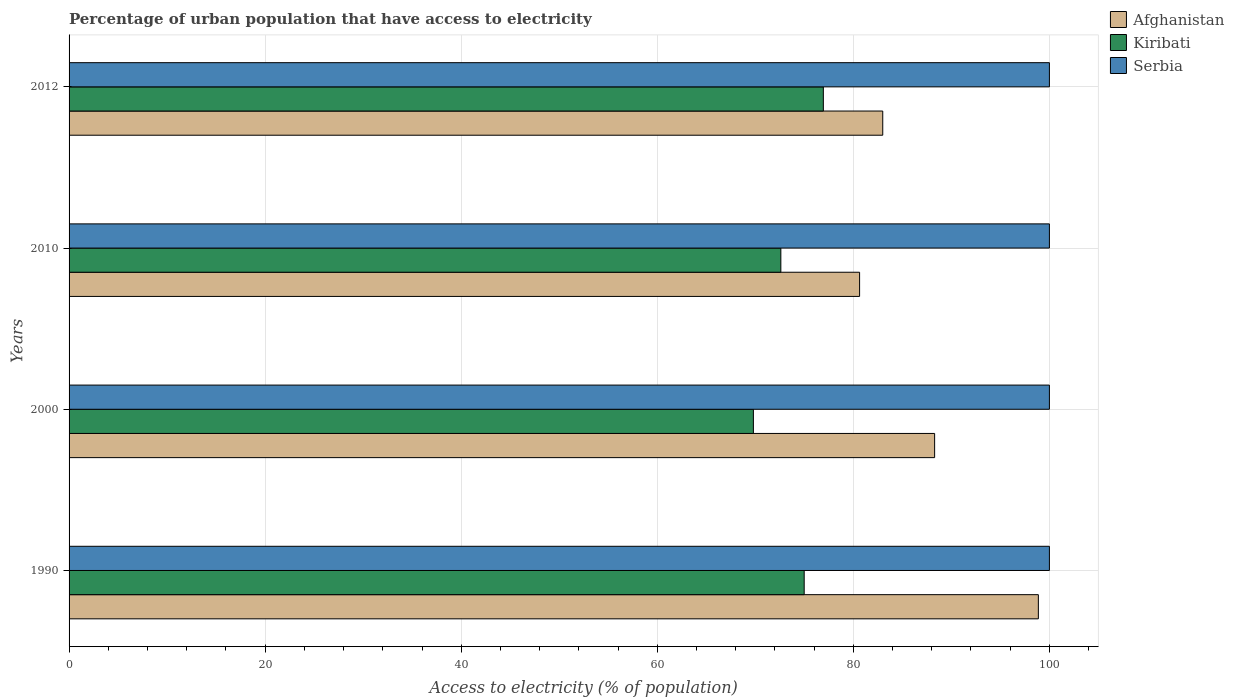Are the number of bars per tick equal to the number of legend labels?
Make the answer very short. Yes. How many bars are there on the 2nd tick from the bottom?
Provide a succinct answer. 3. In how many cases, is the number of bars for a given year not equal to the number of legend labels?
Give a very brief answer. 0. Across all years, what is the maximum percentage of urban population that have access to electricity in Kiribati?
Make the answer very short. 76.94. Across all years, what is the minimum percentage of urban population that have access to electricity in Serbia?
Provide a succinct answer. 100. In which year was the percentage of urban population that have access to electricity in Afghanistan minimum?
Ensure brevity in your answer.  2010. What is the total percentage of urban population that have access to electricity in Afghanistan in the graph?
Your answer should be compact. 350.8. What is the difference between the percentage of urban population that have access to electricity in Kiribati in 2010 and that in 2012?
Ensure brevity in your answer.  -4.34. What is the difference between the percentage of urban population that have access to electricity in Serbia in 2010 and the percentage of urban population that have access to electricity in Afghanistan in 2000?
Your response must be concise. 11.71. What is the average percentage of urban population that have access to electricity in Kiribati per year?
Keep it short and to the point. 73.58. In the year 2012, what is the difference between the percentage of urban population that have access to electricity in Kiribati and percentage of urban population that have access to electricity in Serbia?
Offer a very short reply. -23.06. What is the ratio of the percentage of urban population that have access to electricity in Kiribati in 2000 to that in 2010?
Provide a short and direct response. 0.96. Is the percentage of urban population that have access to electricity in Serbia in 1990 less than that in 2010?
Your response must be concise. No. Is the difference between the percentage of urban population that have access to electricity in Kiribati in 2000 and 2012 greater than the difference between the percentage of urban population that have access to electricity in Serbia in 2000 and 2012?
Offer a terse response. No. What is the difference between the highest and the second highest percentage of urban population that have access to electricity in Kiribati?
Give a very brief answer. 1.95. What is the difference between the highest and the lowest percentage of urban population that have access to electricity in Kiribati?
Keep it short and to the point. 7.13. What does the 2nd bar from the top in 1990 represents?
Keep it short and to the point. Kiribati. What does the 1st bar from the bottom in 2012 represents?
Your answer should be compact. Afghanistan. Is it the case that in every year, the sum of the percentage of urban population that have access to electricity in Afghanistan and percentage of urban population that have access to electricity in Kiribati is greater than the percentage of urban population that have access to electricity in Serbia?
Provide a short and direct response. Yes. Does the graph contain any zero values?
Provide a succinct answer. No. Does the graph contain grids?
Your answer should be very brief. Yes. How many legend labels are there?
Provide a short and direct response. 3. What is the title of the graph?
Provide a short and direct response. Percentage of urban population that have access to electricity. What is the label or title of the X-axis?
Keep it short and to the point. Access to electricity (% of population). What is the Access to electricity (% of population) in Afghanistan in 1990?
Keep it short and to the point. 98.87. What is the Access to electricity (% of population) in Kiribati in 1990?
Your answer should be compact. 74.99. What is the Access to electricity (% of population) of Afghanistan in 2000?
Provide a succinct answer. 88.29. What is the Access to electricity (% of population) in Kiribati in 2000?
Give a very brief answer. 69.8. What is the Access to electricity (% of population) of Serbia in 2000?
Give a very brief answer. 100. What is the Access to electricity (% of population) of Afghanistan in 2010?
Ensure brevity in your answer.  80.64. What is the Access to electricity (% of population) in Kiribati in 2010?
Provide a short and direct response. 72.6. What is the Access to electricity (% of population) in Afghanistan in 2012?
Offer a very short reply. 83. What is the Access to electricity (% of population) of Kiribati in 2012?
Provide a short and direct response. 76.94. Across all years, what is the maximum Access to electricity (% of population) in Afghanistan?
Your response must be concise. 98.87. Across all years, what is the maximum Access to electricity (% of population) in Kiribati?
Provide a short and direct response. 76.94. Across all years, what is the maximum Access to electricity (% of population) of Serbia?
Offer a very short reply. 100. Across all years, what is the minimum Access to electricity (% of population) of Afghanistan?
Offer a terse response. 80.64. Across all years, what is the minimum Access to electricity (% of population) of Kiribati?
Provide a short and direct response. 69.8. What is the total Access to electricity (% of population) in Afghanistan in the graph?
Ensure brevity in your answer.  350.8. What is the total Access to electricity (% of population) in Kiribati in the graph?
Keep it short and to the point. 294.33. What is the difference between the Access to electricity (% of population) in Afghanistan in 1990 and that in 2000?
Offer a terse response. 10.58. What is the difference between the Access to electricity (% of population) of Kiribati in 1990 and that in 2000?
Your answer should be very brief. 5.18. What is the difference between the Access to electricity (% of population) of Serbia in 1990 and that in 2000?
Keep it short and to the point. 0. What is the difference between the Access to electricity (% of population) in Afghanistan in 1990 and that in 2010?
Your response must be concise. 18.24. What is the difference between the Access to electricity (% of population) of Kiribati in 1990 and that in 2010?
Provide a short and direct response. 2.38. What is the difference between the Access to electricity (% of population) in Serbia in 1990 and that in 2010?
Your response must be concise. 0. What is the difference between the Access to electricity (% of population) in Afghanistan in 1990 and that in 2012?
Make the answer very short. 15.87. What is the difference between the Access to electricity (% of population) in Kiribati in 1990 and that in 2012?
Your answer should be compact. -1.95. What is the difference between the Access to electricity (% of population) of Serbia in 1990 and that in 2012?
Make the answer very short. 0. What is the difference between the Access to electricity (% of population) in Afghanistan in 2000 and that in 2010?
Your answer should be compact. 7.65. What is the difference between the Access to electricity (% of population) of Kiribati in 2000 and that in 2010?
Provide a short and direct response. -2.8. What is the difference between the Access to electricity (% of population) of Serbia in 2000 and that in 2010?
Provide a short and direct response. 0. What is the difference between the Access to electricity (% of population) of Afghanistan in 2000 and that in 2012?
Offer a very short reply. 5.29. What is the difference between the Access to electricity (% of population) of Kiribati in 2000 and that in 2012?
Your answer should be compact. -7.13. What is the difference between the Access to electricity (% of population) in Afghanistan in 2010 and that in 2012?
Your answer should be very brief. -2.36. What is the difference between the Access to electricity (% of population) in Kiribati in 2010 and that in 2012?
Your answer should be compact. -4.34. What is the difference between the Access to electricity (% of population) of Serbia in 2010 and that in 2012?
Offer a very short reply. 0. What is the difference between the Access to electricity (% of population) of Afghanistan in 1990 and the Access to electricity (% of population) of Kiribati in 2000?
Offer a very short reply. 29.07. What is the difference between the Access to electricity (% of population) of Afghanistan in 1990 and the Access to electricity (% of population) of Serbia in 2000?
Your answer should be compact. -1.13. What is the difference between the Access to electricity (% of population) of Kiribati in 1990 and the Access to electricity (% of population) of Serbia in 2000?
Offer a very short reply. -25.01. What is the difference between the Access to electricity (% of population) of Afghanistan in 1990 and the Access to electricity (% of population) of Kiribati in 2010?
Provide a short and direct response. 26.27. What is the difference between the Access to electricity (% of population) in Afghanistan in 1990 and the Access to electricity (% of population) in Serbia in 2010?
Provide a short and direct response. -1.13. What is the difference between the Access to electricity (% of population) in Kiribati in 1990 and the Access to electricity (% of population) in Serbia in 2010?
Provide a succinct answer. -25.01. What is the difference between the Access to electricity (% of population) in Afghanistan in 1990 and the Access to electricity (% of population) in Kiribati in 2012?
Offer a terse response. 21.93. What is the difference between the Access to electricity (% of population) of Afghanistan in 1990 and the Access to electricity (% of population) of Serbia in 2012?
Your response must be concise. -1.13. What is the difference between the Access to electricity (% of population) in Kiribati in 1990 and the Access to electricity (% of population) in Serbia in 2012?
Make the answer very short. -25.01. What is the difference between the Access to electricity (% of population) in Afghanistan in 2000 and the Access to electricity (% of population) in Kiribati in 2010?
Provide a short and direct response. 15.69. What is the difference between the Access to electricity (% of population) in Afghanistan in 2000 and the Access to electricity (% of population) in Serbia in 2010?
Give a very brief answer. -11.71. What is the difference between the Access to electricity (% of population) in Kiribati in 2000 and the Access to electricity (% of population) in Serbia in 2010?
Keep it short and to the point. -30.2. What is the difference between the Access to electricity (% of population) of Afghanistan in 2000 and the Access to electricity (% of population) of Kiribati in 2012?
Give a very brief answer. 11.35. What is the difference between the Access to electricity (% of population) in Afghanistan in 2000 and the Access to electricity (% of population) in Serbia in 2012?
Your answer should be compact. -11.71. What is the difference between the Access to electricity (% of population) in Kiribati in 2000 and the Access to electricity (% of population) in Serbia in 2012?
Make the answer very short. -30.2. What is the difference between the Access to electricity (% of population) of Afghanistan in 2010 and the Access to electricity (% of population) of Kiribati in 2012?
Your response must be concise. 3.7. What is the difference between the Access to electricity (% of population) in Afghanistan in 2010 and the Access to electricity (% of population) in Serbia in 2012?
Keep it short and to the point. -19.36. What is the difference between the Access to electricity (% of population) of Kiribati in 2010 and the Access to electricity (% of population) of Serbia in 2012?
Your answer should be compact. -27.4. What is the average Access to electricity (% of population) in Afghanistan per year?
Provide a short and direct response. 87.7. What is the average Access to electricity (% of population) in Kiribati per year?
Your response must be concise. 73.58. In the year 1990, what is the difference between the Access to electricity (% of population) in Afghanistan and Access to electricity (% of population) in Kiribati?
Your response must be concise. 23.89. In the year 1990, what is the difference between the Access to electricity (% of population) of Afghanistan and Access to electricity (% of population) of Serbia?
Offer a very short reply. -1.13. In the year 1990, what is the difference between the Access to electricity (% of population) of Kiribati and Access to electricity (% of population) of Serbia?
Ensure brevity in your answer.  -25.01. In the year 2000, what is the difference between the Access to electricity (% of population) in Afghanistan and Access to electricity (% of population) in Kiribati?
Offer a very short reply. 18.49. In the year 2000, what is the difference between the Access to electricity (% of population) in Afghanistan and Access to electricity (% of population) in Serbia?
Offer a very short reply. -11.71. In the year 2000, what is the difference between the Access to electricity (% of population) in Kiribati and Access to electricity (% of population) in Serbia?
Offer a terse response. -30.2. In the year 2010, what is the difference between the Access to electricity (% of population) in Afghanistan and Access to electricity (% of population) in Kiribati?
Offer a terse response. 8.03. In the year 2010, what is the difference between the Access to electricity (% of population) in Afghanistan and Access to electricity (% of population) in Serbia?
Ensure brevity in your answer.  -19.36. In the year 2010, what is the difference between the Access to electricity (% of population) of Kiribati and Access to electricity (% of population) of Serbia?
Provide a short and direct response. -27.4. In the year 2012, what is the difference between the Access to electricity (% of population) in Afghanistan and Access to electricity (% of population) in Kiribati?
Make the answer very short. 6.06. In the year 2012, what is the difference between the Access to electricity (% of population) in Afghanistan and Access to electricity (% of population) in Serbia?
Keep it short and to the point. -17. In the year 2012, what is the difference between the Access to electricity (% of population) in Kiribati and Access to electricity (% of population) in Serbia?
Make the answer very short. -23.06. What is the ratio of the Access to electricity (% of population) of Afghanistan in 1990 to that in 2000?
Your answer should be compact. 1.12. What is the ratio of the Access to electricity (% of population) in Kiribati in 1990 to that in 2000?
Offer a terse response. 1.07. What is the ratio of the Access to electricity (% of population) in Serbia in 1990 to that in 2000?
Provide a short and direct response. 1. What is the ratio of the Access to electricity (% of population) in Afghanistan in 1990 to that in 2010?
Provide a short and direct response. 1.23. What is the ratio of the Access to electricity (% of population) of Kiribati in 1990 to that in 2010?
Give a very brief answer. 1.03. What is the ratio of the Access to electricity (% of population) in Serbia in 1990 to that in 2010?
Provide a short and direct response. 1. What is the ratio of the Access to electricity (% of population) of Afghanistan in 1990 to that in 2012?
Ensure brevity in your answer.  1.19. What is the ratio of the Access to electricity (% of population) in Kiribati in 1990 to that in 2012?
Give a very brief answer. 0.97. What is the ratio of the Access to electricity (% of population) in Afghanistan in 2000 to that in 2010?
Your answer should be very brief. 1.09. What is the ratio of the Access to electricity (% of population) of Kiribati in 2000 to that in 2010?
Your response must be concise. 0.96. What is the ratio of the Access to electricity (% of population) of Serbia in 2000 to that in 2010?
Give a very brief answer. 1. What is the ratio of the Access to electricity (% of population) in Afghanistan in 2000 to that in 2012?
Provide a short and direct response. 1.06. What is the ratio of the Access to electricity (% of population) in Kiribati in 2000 to that in 2012?
Make the answer very short. 0.91. What is the ratio of the Access to electricity (% of population) in Serbia in 2000 to that in 2012?
Provide a succinct answer. 1. What is the ratio of the Access to electricity (% of population) in Afghanistan in 2010 to that in 2012?
Give a very brief answer. 0.97. What is the ratio of the Access to electricity (% of population) in Kiribati in 2010 to that in 2012?
Keep it short and to the point. 0.94. What is the ratio of the Access to electricity (% of population) of Serbia in 2010 to that in 2012?
Make the answer very short. 1. What is the difference between the highest and the second highest Access to electricity (% of population) of Afghanistan?
Offer a very short reply. 10.58. What is the difference between the highest and the second highest Access to electricity (% of population) of Kiribati?
Your answer should be compact. 1.95. What is the difference between the highest and the lowest Access to electricity (% of population) in Afghanistan?
Your answer should be very brief. 18.24. What is the difference between the highest and the lowest Access to electricity (% of population) in Kiribati?
Offer a terse response. 7.13. 